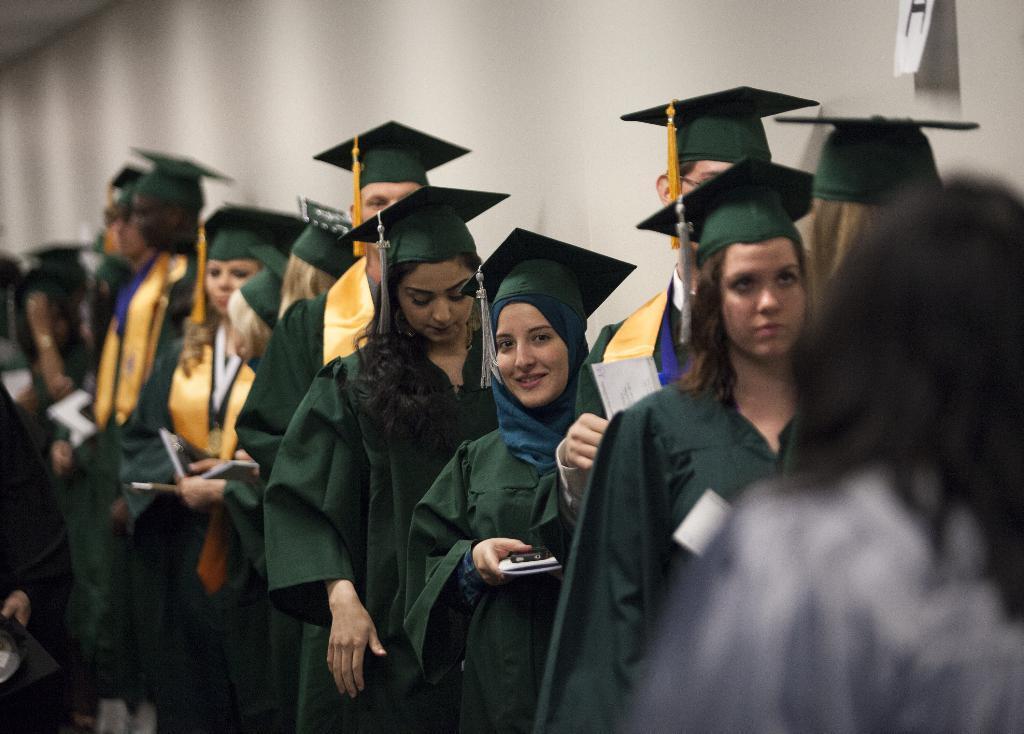In one or two sentences, can you explain what this image depicts? In this image we can see there are people standing and holding a pen, paper and the black color object. At the back there is a wall and paper attached to the wall. 